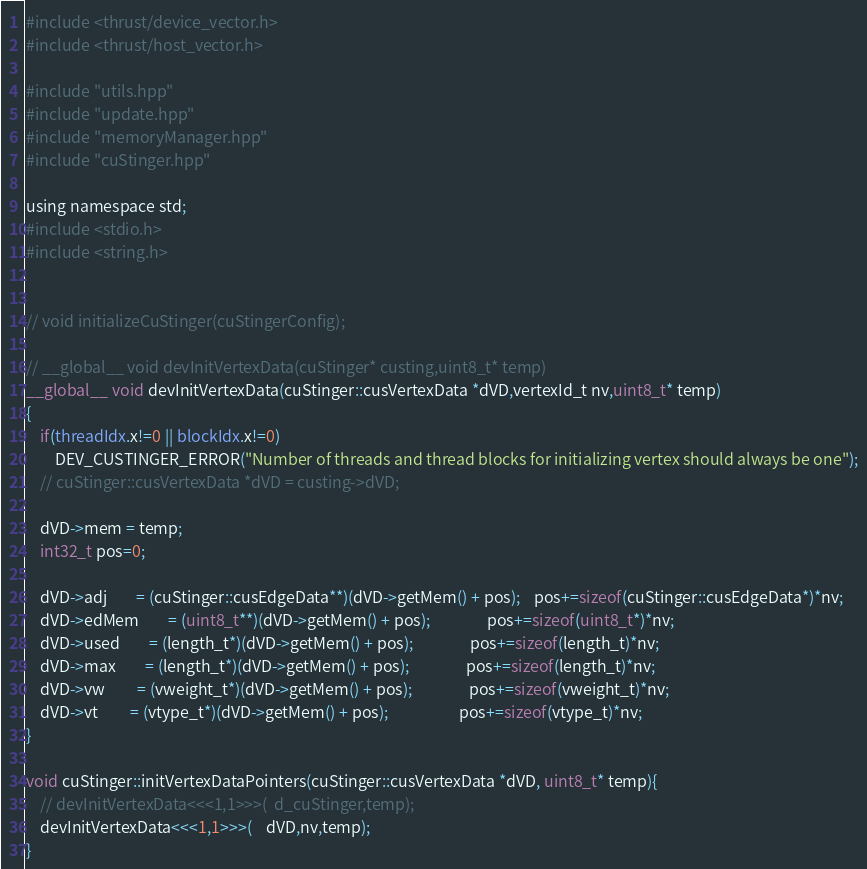Convert code to text. <code><loc_0><loc_0><loc_500><loc_500><_Cuda_>
#include <thrust/device_vector.h>
#include <thrust/host_vector.h>

#include "utils.hpp"
#include "update.hpp"
#include "memoryManager.hpp"
#include "cuStinger.hpp"

using namespace std;
#include <stdio.h>
#include <string.h>


// void initializeCuStinger(cuStingerConfig);

// __global__ void devInitVertexData(cuStinger* custing,uint8_t* temp)
__global__ void devInitVertexData(cuStinger::cusVertexData *dVD,vertexId_t nv,uint8_t* temp)
{
	if(threadIdx.x!=0 || blockIdx.x!=0)
		DEV_CUSTINGER_ERROR("Number of threads and thread blocks for initializing vertex should always be one");
	// cuStinger::cusVertexData *dVD = custing->dVD;

	dVD->mem = temp;
	int32_t pos=0;

	dVD->adj 		= (cuStinger::cusEdgeData**)(dVD->getMem() + pos); 	pos+=sizeof(cuStinger::cusEdgeData*)*nv;
	dVD->edMem 		= (uint8_t**)(dVD->getMem() + pos); 				pos+=sizeof(uint8_t*)*nv;
	dVD->used 		= (length_t*)(dVD->getMem() + pos); 				pos+=sizeof(length_t)*nv;
	dVD->max        = (length_t*)(dVD->getMem() + pos); 				pos+=sizeof(length_t)*nv;
	dVD->vw         = (vweight_t*)(dVD->getMem() + pos); 				pos+=sizeof(vweight_t)*nv;
	dVD->vt         = (vtype_t*)(dVD->getMem() + pos); 					pos+=sizeof(vtype_t)*nv;
}

void cuStinger::initVertexDataPointers(cuStinger::cusVertexData *dVD, uint8_t* temp){
	// devInitVertexData<<<1,1>>>(	d_cuStinger,temp);
	devInitVertexData<<<1,1>>>(	dVD,nv,temp);
}
</code> 